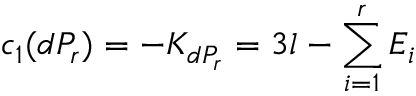Convert formula to latex. <formula><loc_0><loc_0><loc_500><loc_500>c _ { 1 } ( d P _ { r } ) = - K _ { d P _ { r } } = 3 l - \sum _ { i = 1 } ^ { r } { E _ { i } }</formula> 